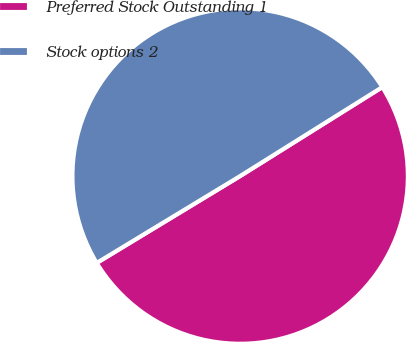Convert chart. <chart><loc_0><loc_0><loc_500><loc_500><pie_chart><fcel>Preferred Stock Outstanding 1<fcel>Stock options 2<nl><fcel>50.23%<fcel>49.77%<nl></chart> 